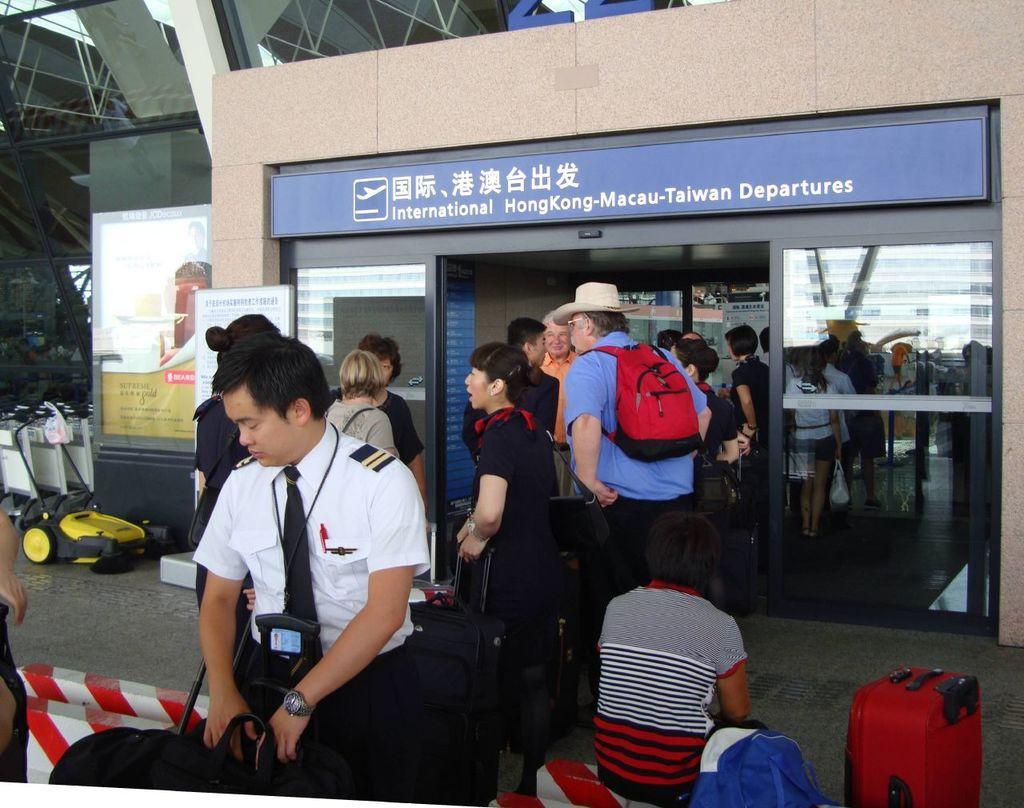Can you describe this image briefly? In this Image I see number of people who are carrying their luggage and I see a boy over here who is sitting, I can also see that this is an airport. 